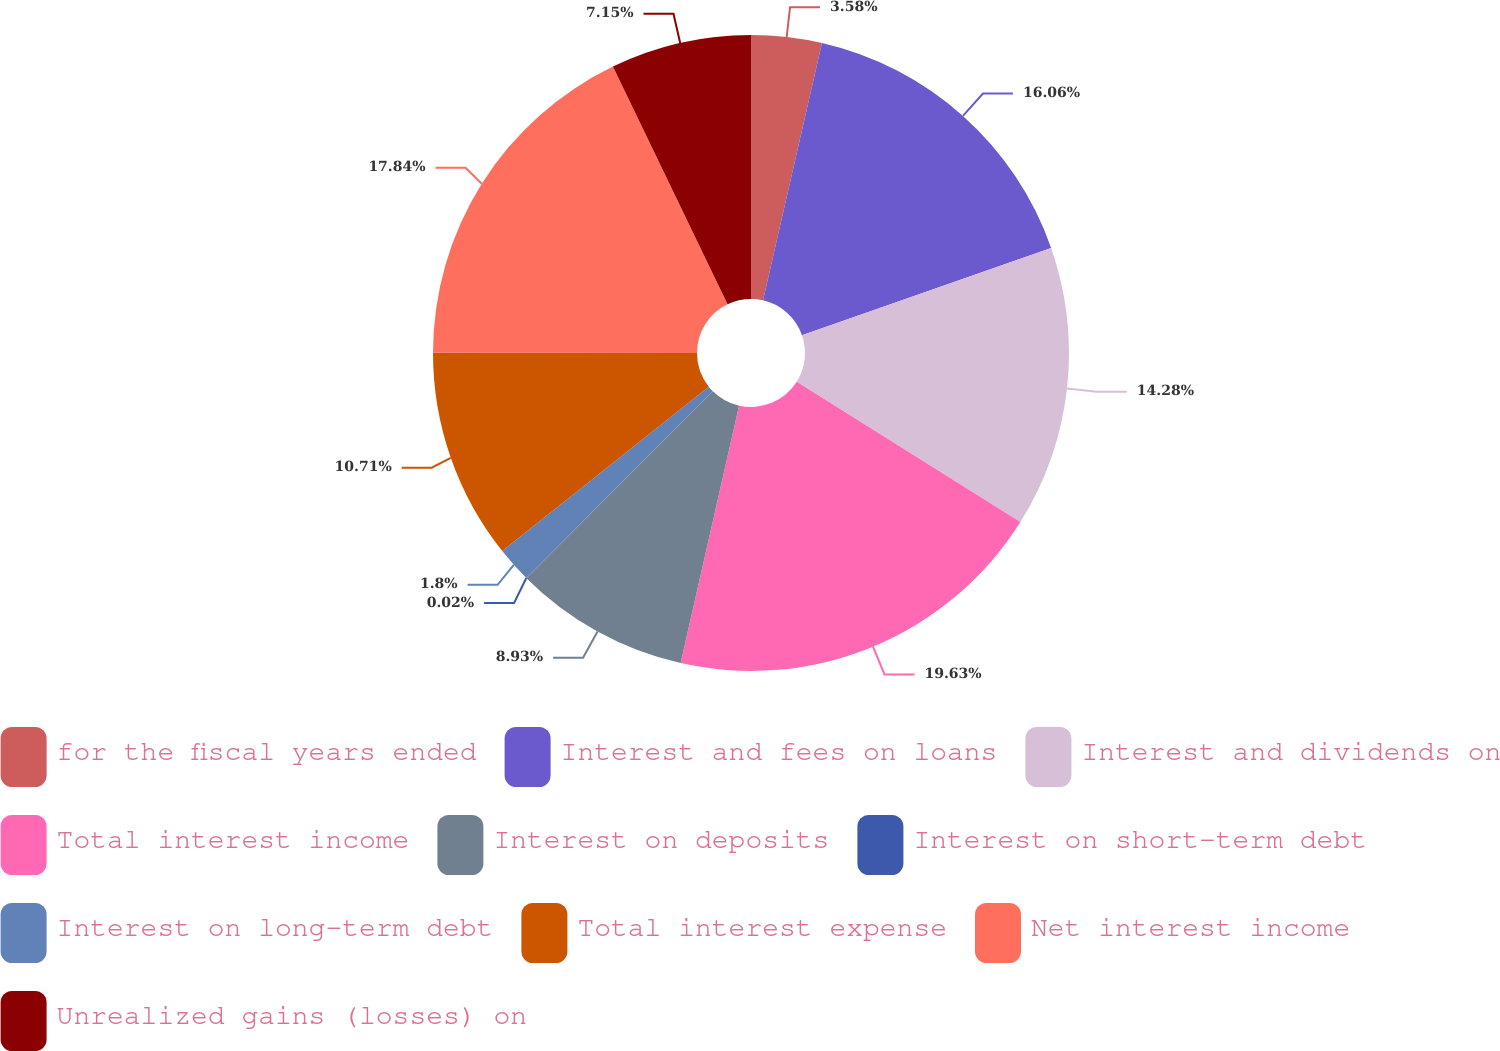Convert chart to OTSL. <chart><loc_0><loc_0><loc_500><loc_500><pie_chart><fcel>for the fiscal years ended<fcel>Interest and fees on loans<fcel>Interest and dividends on<fcel>Total interest income<fcel>Interest on deposits<fcel>Interest on short-term debt<fcel>Interest on long-term debt<fcel>Total interest expense<fcel>Net interest income<fcel>Unrealized gains (losses) on<nl><fcel>3.58%<fcel>16.06%<fcel>14.28%<fcel>19.63%<fcel>8.93%<fcel>0.02%<fcel>1.8%<fcel>10.71%<fcel>17.84%<fcel>7.15%<nl></chart> 